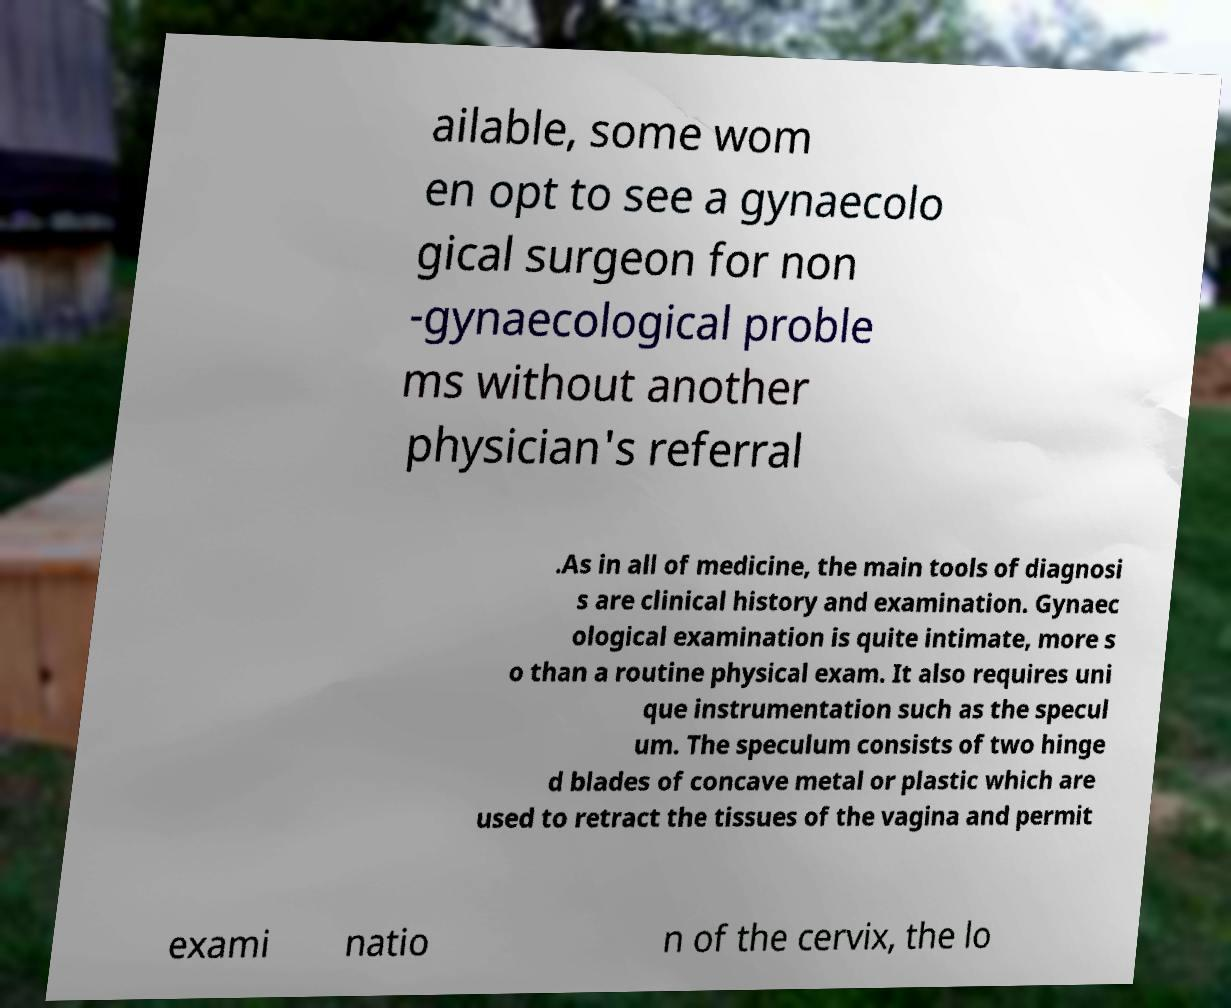There's text embedded in this image that I need extracted. Can you transcribe it verbatim? ailable, some wom en opt to see a gynaecolo gical surgeon for non -gynaecological proble ms without another physician's referral .As in all of medicine, the main tools of diagnosi s are clinical history and examination. Gynaec ological examination is quite intimate, more s o than a routine physical exam. It also requires uni que instrumentation such as the specul um. The speculum consists of two hinge d blades of concave metal or plastic which are used to retract the tissues of the vagina and permit exami natio n of the cervix, the lo 